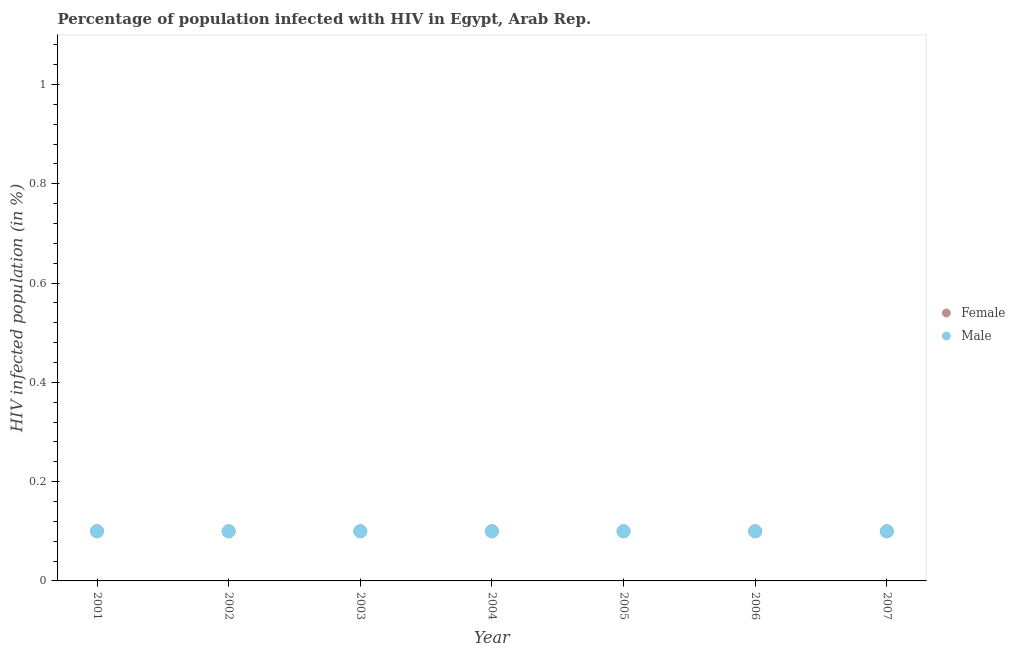Is the number of dotlines equal to the number of legend labels?
Your answer should be compact. Yes. What is the percentage of females who are infected with hiv in 2007?
Give a very brief answer. 0.1. In which year was the percentage of females who are infected with hiv maximum?
Ensure brevity in your answer.  2001. What is the difference between the percentage of females who are infected with hiv in 2002 and that in 2005?
Offer a very short reply. 0. What is the average percentage of females who are infected with hiv per year?
Ensure brevity in your answer.  0.1. In the year 2006, what is the difference between the percentage of males who are infected with hiv and percentage of females who are infected with hiv?
Your answer should be compact. 0. In how many years, is the percentage of females who are infected with hiv greater than 0.68 %?
Your response must be concise. 0. Is the percentage of females who are infected with hiv in 2002 less than that in 2003?
Provide a succinct answer. No. What is the difference between the highest and the lowest percentage of females who are infected with hiv?
Give a very brief answer. 0. Does the percentage of females who are infected with hiv monotonically increase over the years?
Ensure brevity in your answer.  No. How many years are there in the graph?
Make the answer very short. 7. Are the values on the major ticks of Y-axis written in scientific E-notation?
Make the answer very short. No. Does the graph contain any zero values?
Give a very brief answer. No. What is the title of the graph?
Offer a terse response. Percentage of population infected with HIV in Egypt, Arab Rep. What is the label or title of the Y-axis?
Your answer should be compact. HIV infected population (in %). What is the HIV infected population (in %) in Female in 2003?
Ensure brevity in your answer.  0.1. What is the HIV infected population (in %) in Female in 2004?
Offer a very short reply. 0.1. What is the HIV infected population (in %) of Female in 2005?
Provide a succinct answer. 0.1. What is the HIV infected population (in %) in Female in 2006?
Ensure brevity in your answer.  0.1. What is the HIV infected population (in %) in Male in 2006?
Your response must be concise. 0.1. What is the HIV infected population (in %) in Female in 2007?
Provide a short and direct response. 0.1. Across all years, what is the maximum HIV infected population (in %) of Male?
Your response must be concise. 0.1. Across all years, what is the minimum HIV infected population (in %) in Female?
Provide a short and direct response. 0.1. Across all years, what is the minimum HIV infected population (in %) of Male?
Your answer should be very brief. 0.1. What is the total HIV infected population (in %) of Female in the graph?
Offer a terse response. 0.7. What is the difference between the HIV infected population (in %) in Male in 2001 and that in 2002?
Your response must be concise. 0. What is the difference between the HIV infected population (in %) in Male in 2001 and that in 2003?
Offer a very short reply. 0. What is the difference between the HIV infected population (in %) of Female in 2001 and that in 2004?
Offer a terse response. 0. What is the difference between the HIV infected population (in %) of Male in 2001 and that in 2004?
Your answer should be very brief. 0. What is the difference between the HIV infected population (in %) of Male in 2001 and that in 2005?
Your response must be concise. 0. What is the difference between the HIV infected population (in %) of Female in 2001 and that in 2006?
Give a very brief answer. 0. What is the difference between the HIV infected population (in %) of Male in 2001 and that in 2006?
Ensure brevity in your answer.  0. What is the difference between the HIV infected population (in %) in Female in 2001 and that in 2007?
Make the answer very short. 0. What is the difference between the HIV infected population (in %) in Male in 2001 and that in 2007?
Keep it short and to the point. 0. What is the difference between the HIV infected population (in %) of Female in 2002 and that in 2004?
Ensure brevity in your answer.  0. What is the difference between the HIV infected population (in %) in Female in 2002 and that in 2005?
Offer a very short reply. 0. What is the difference between the HIV infected population (in %) in Male in 2002 and that in 2005?
Keep it short and to the point. 0. What is the difference between the HIV infected population (in %) in Male in 2002 and that in 2006?
Offer a very short reply. 0. What is the difference between the HIV infected population (in %) of Male in 2002 and that in 2007?
Your answer should be very brief. 0. What is the difference between the HIV infected population (in %) of Female in 2003 and that in 2004?
Give a very brief answer. 0. What is the difference between the HIV infected population (in %) of Male in 2003 and that in 2004?
Offer a very short reply. 0. What is the difference between the HIV infected population (in %) in Female in 2003 and that in 2005?
Give a very brief answer. 0. What is the difference between the HIV infected population (in %) in Female in 2003 and that in 2006?
Offer a terse response. 0. What is the difference between the HIV infected population (in %) in Male in 2003 and that in 2006?
Your answer should be compact. 0. What is the difference between the HIV infected population (in %) in Male in 2004 and that in 2006?
Your answer should be compact. 0. What is the difference between the HIV infected population (in %) in Female in 2004 and that in 2007?
Ensure brevity in your answer.  0. What is the difference between the HIV infected population (in %) of Male in 2004 and that in 2007?
Ensure brevity in your answer.  0. What is the difference between the HIV infected population (in %) in Female in 2005 and that in 2006?
Give a very brief answer. 0. What is the difference between the HIV infected population (in %) of Male in 2005 and that in 2006?
Ensure brevity in your answer.  0. What is the difference between the HIV infected population (in %) in Female in 2005 and that in 2007?
Your answer should be very brief. 0. What is the difference between the HIV infected population (in %) of Female in 2006 and that in 2007?
Provide a short and direct response. 0. What is the difference between the HIV infected population (in %) in Male in 2006 and that in 2007?
Offer a very short reply. 0. What is the difference between the HIV infected population (in %) of Female in 2001 and the HIV infected population (in %) of Male in 2002?
Your answer should be compact. 0. What is the difference between the HIV infected population (in %) in Female in 2001 and the HIV infected population (in %) in Male in 2003?
Provide a succinct answer. 0. What is the difference between the HIV infected population (in %) in Female in 2001 and the HIV infected population (in %) in Male in 2004?
Your response must be concise. 0. What is the difference between the HIV infected population (in %) of Female in 2002 and the HIV infected population (in %) of Male in 2003?
Your answer should be very brief. 0. What is the difference between the HIV infected population (in %) in Female in 2002 and the HIV infected population (in %) in Male in 2004?
Your answer should be compact. 0. What is the difference between the HIV infected population (in %) in Female in 2002 and the HIV infected population (in %) in Male in 2005?
Give a very brief answer. 0. What is the difference between the HIV infected population (in %) of Female in 2002 and the HIV infected population (in %) of Male in 2006?
Ensure brevity in your answer.  0. What is the difference between the HIV infected population (in %) of Female in 2002 and the HIV infected population (in %) of Male in 2007?
Provide a short and direct response. 0. What is the difference between the HIV infected population (in %) of Female in 2003 and the HIV infected population (in %) of Male in 2004?
Keep it short and to the point. 0. What is the difference between the HIV infected population (in %) in Female in 2003 and the HIV infected population (in %) in Male in 2007?
Keep it short and to the point. 0. What is the difference between the HIV infected population (in %) of Female in 2004 and the HIV infected population (in %) of Male in 2005?
Offer a very short reply. 0. What is the difference between the HIV infected population (in %) of Female in 2004 and the HIV infected population (in %) of Male in 2006?
Your answer should be very brief. 0. What is the difference between the HIV infected population (in %) in Female in 2004 and the HIV infected population (in %) in Male in 2007?
Offer a very short reply. 0. What is the difference between the HIV infected population (in %) of Female in 2005 and the HIV infected population (in %) of Male in 2006?
Your answer should be compact. 0. What is the difference between the HIV infected population (in %) of Female in 2005 and the HIV infected population (in %) of Male in 2007?
Your answer should be very brief. 0. What is the difference between the HIV infected population (in %) of Female in 2006 and the HIV infected population (in %) of Male in 2007?
Provide a short and direct response. 0. What is the average HIV infected population (in %) in Female per year?
Keep it short and to the point. 0.1. In the year 2001, what is the difference between the HIV infected population (in %) of Female and HIV infected population (in %) of Male?
Ensure brevity in your answer.  0. In the year 2004, what is the difference between the HIV infected population (in %) of Female and HIV infected population (in %) of Male?
Your response must be concise. 0. In the year 2007, what is the difference between the HIV infected population (in %) of Female and HIV infected population (in %) of Male?
Your answer should be very brief. 0. What is the ratio of the HIV infected population (in %) of Female in 2001 to that in 2003?
Give a very brief answer. 1. What is the ratio of the HIV infected population (in %) in Female in 2001 to that in 2005?
Keep it short and to the point. 1. What is the ratio of the HIV infected population (in %) of Male in 2001 to that in 2006?
Your answer should be compact. 1. What is the ratio of the HIV infected population (in %) of Female in 2002 to that in 2004?
Keep it short and to the point. 1. What is the ratio of the HIV infected population (in %) in Male in 2002 to that in 2004?
Ensure brevity in your answer.  1. What is the ratio of the HIV infected population (in %) in Female in 2002 to that in 2005?
Give a very brief answer. 1. What is the ratio of the HIV infected population (in %) of Female in 2002 to that in 2006?
Keep it short and to the point. 1. What is the ratio of the HIV infected population (in %) in Female in 2002 to that in 2007?
Ensure brevity in your answer.  1. What is the ratio of the HIV infected population (in %) in Female in 2003 to that in 2004?
Your answer should be very brief. 1. What is the ratio of the HIV infected population (in %) in Male in 2003 to that in 2004?
Ensure brevity in your answer.  1. What is the ratio of the HIV infected population (in %) in Female in 2003 to that in 2005?
Your response must be concise. 1. What is the ratio of the HIV infected population (in %) in Male in 2003 to that in 2006?
Keep it short and to the point. 1. What is the ratio of the HIV infected population (in %) in Male in 2003 to that in 2007?
Your answer should be compact. 1. What is the ratio of the HIV infected population (in %) in Female in 2004 to that in 2005?
Give a very brief answer. 1. What is the ratio of the HIV infected population (in %) of Female in 2004 to that in 2006?
Keep it short and to the point. 1. What is the ratio of the HIV infected population (in %) in Male in 2004 to that in 2006?
Offer a terse response. 1. What is the ratio of the HIV infected population (in %) in Female in 2005 to that in 2006?
Offer a very short reply. 1. What is the ratio of the HIV infected population (in %) in Female in 2005 to that in 2007?
Provide a succinct answer. 1. What is the ratio of the HIV infected population (in %) of Male in 2006 to that in 2007?
Offer a terse response. 1. What is the difference between the highest and the lowest HIV infected population (in %) of Male?
Your answer should be compact. 0. 